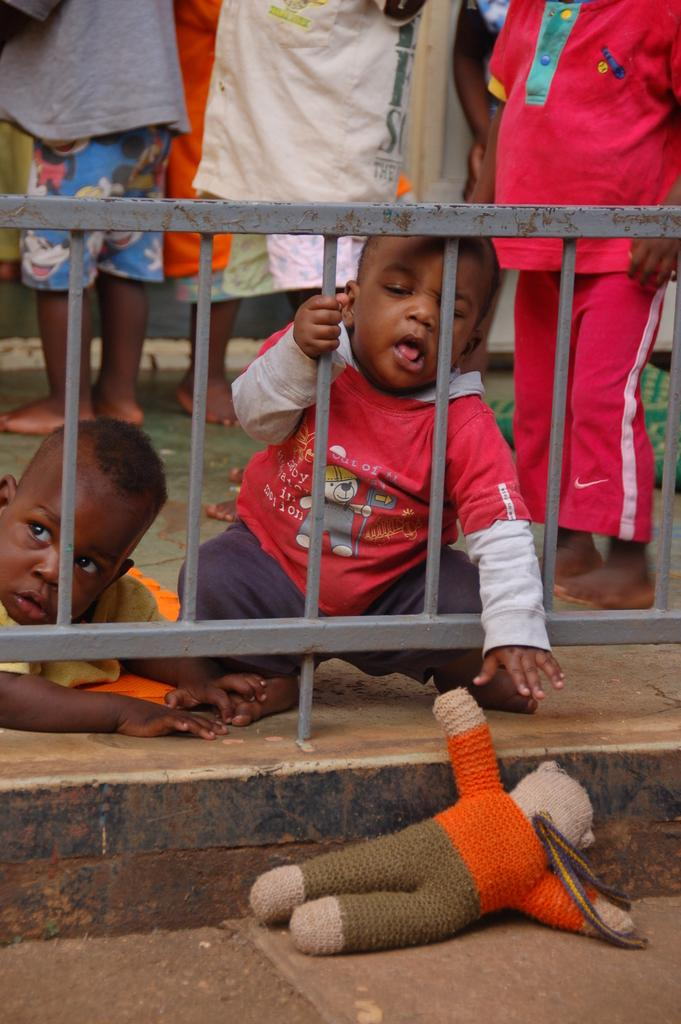How many kids are present in the image? There are two kids in the image. What is the location of the kids in relation to the fence? The kids are behind the fence in the image. What can be seen on the floor in the image? There is a toy on the floor in the image. Are there any other people visible in the image besides the kids? Yes, there are persons standing behind the fence in the image. How many kittens are playing with the stone in the image? There are no kittens or stones present in the image. What is the plot of the story unfolding in the image? The image does not depict a story or plot; it is a static scene. 